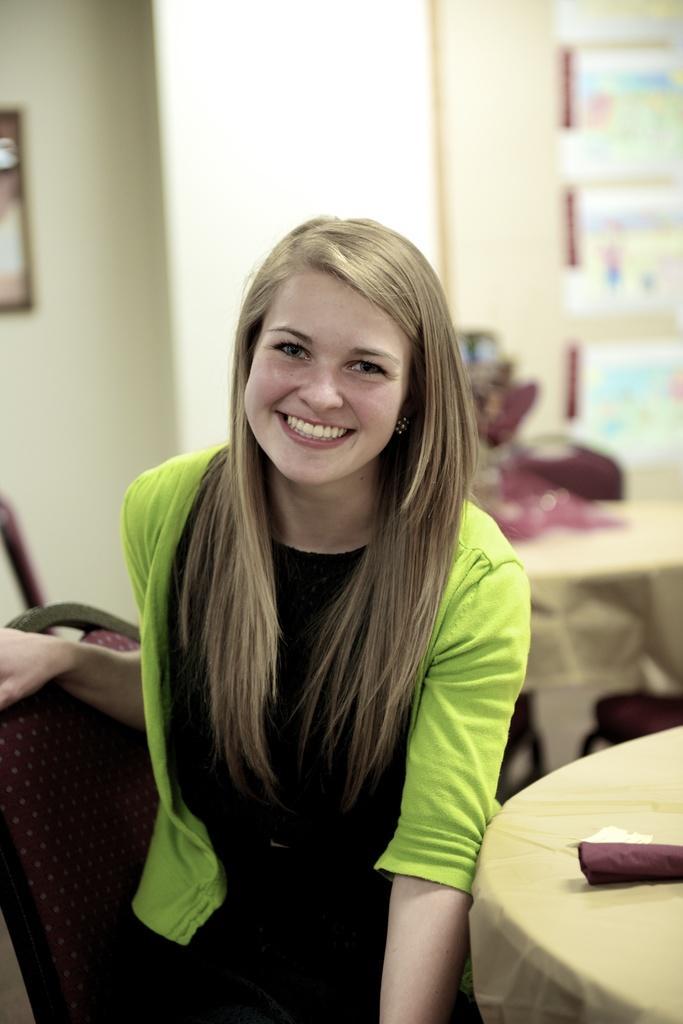How would you summarize this image in a sentence or two? In this image i can see a woman wearing a green jacket and black dress sitting on a chair. I can see smile on her face and in the background i can see a wall and a photo frame attached to it. 